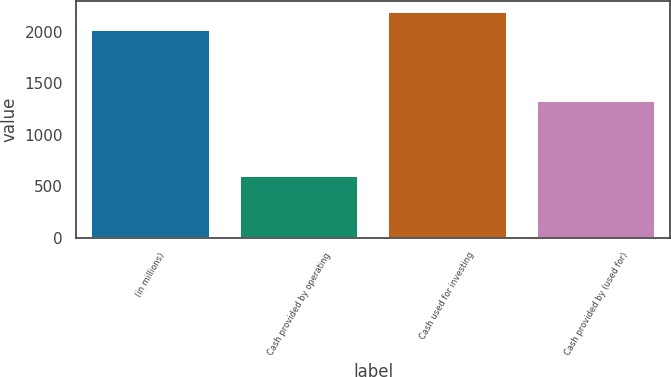<chart> <loc_0><loc_0><loc_500><loc_500><bar_chart><fcel>(in millions)<fcel>Cash provided by operating<fcel>Cash used for investing<fcel>Cash provided by (used for)<nl><fcel>2015<fcel>600<fcel>2186<fcel>1322<nl></chart> 